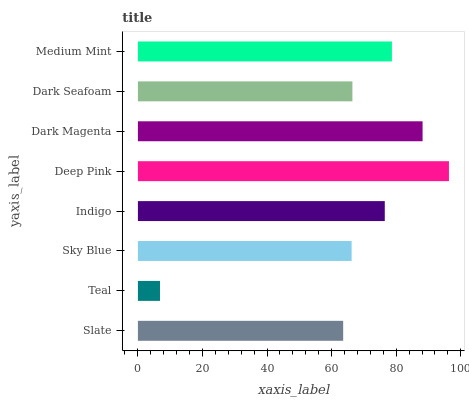Is Teal the minimum?
Answer yes or no. Yes. Is Deep Pink the maximum?
Answer yes or no. Yes. Is Sky Blue the minimum?
Answer yes or no. No. Is Sky Blue the maximum?
Answer yes or no. No. Is Sky Blue greater than Teal?
Answer yes or no. Yes. Is Teal less than Sky Blue?
Answer yes or no. Yes. Is Teal greater than Sky Blue?
Answer yes or no. No. Is Sky Blue less than Teal?
Answer yes or no. No. Is Indigo the high median?
Answer yes or no. Yes. Is Dark Seafoam the low median?
Answer yes or no. Yes. Is Dark Magenta the high median?
Answer yes or no. No. Is Indigo the low median?
Answer yes or no. No. 